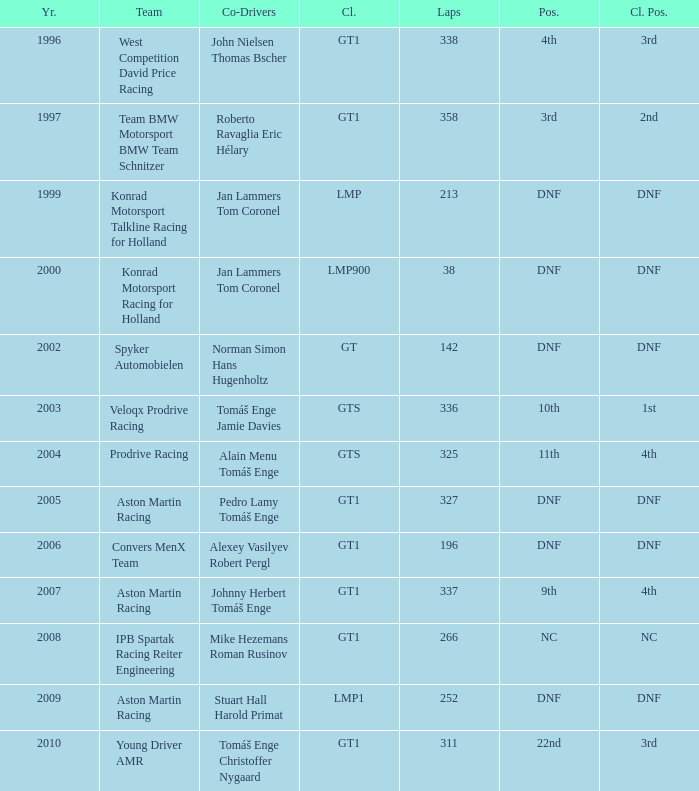Which position finished 3rd in class and completed less than 338 laps? 22nd. 